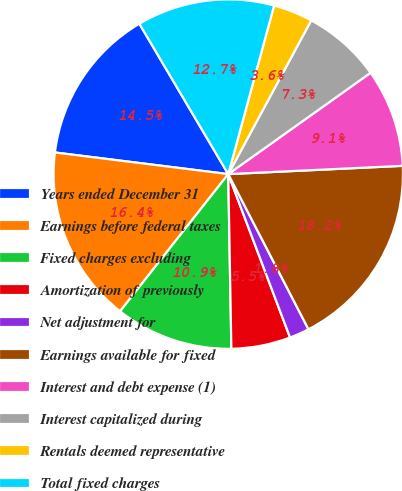Convert chart to OTSL. <chart><loc_0><loc_0><loc_500><loc_500><pie_chart><fcel>Years ended December 31<fcel>Earnings before federal taxes<fcel>Fixed charges excluding<fcel>Amortization of previously<fcel>Net adjustment for<fcel>Earnings available for fixed<fcel>Interest and debt expense (1)<fcel>Interest capitalized during<fcel>Rentals deemed representative<fcel>Total fixed charges<nl><fcel>14.53%<fcel>16.35%<fcel>10.91%<fcel>5.47%<fcel>1.84%<fcel>18.16%<fcel>9.09%<fcel>7.28%<fcel>3.65%<fcel>12.72%<nl></chart> 